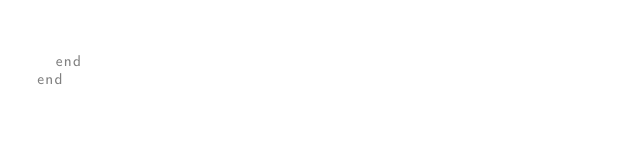Convert code to text. <code><loc_0><loc_0><loc_500><loc_500><_Ruby_>
  end
end
</code> 